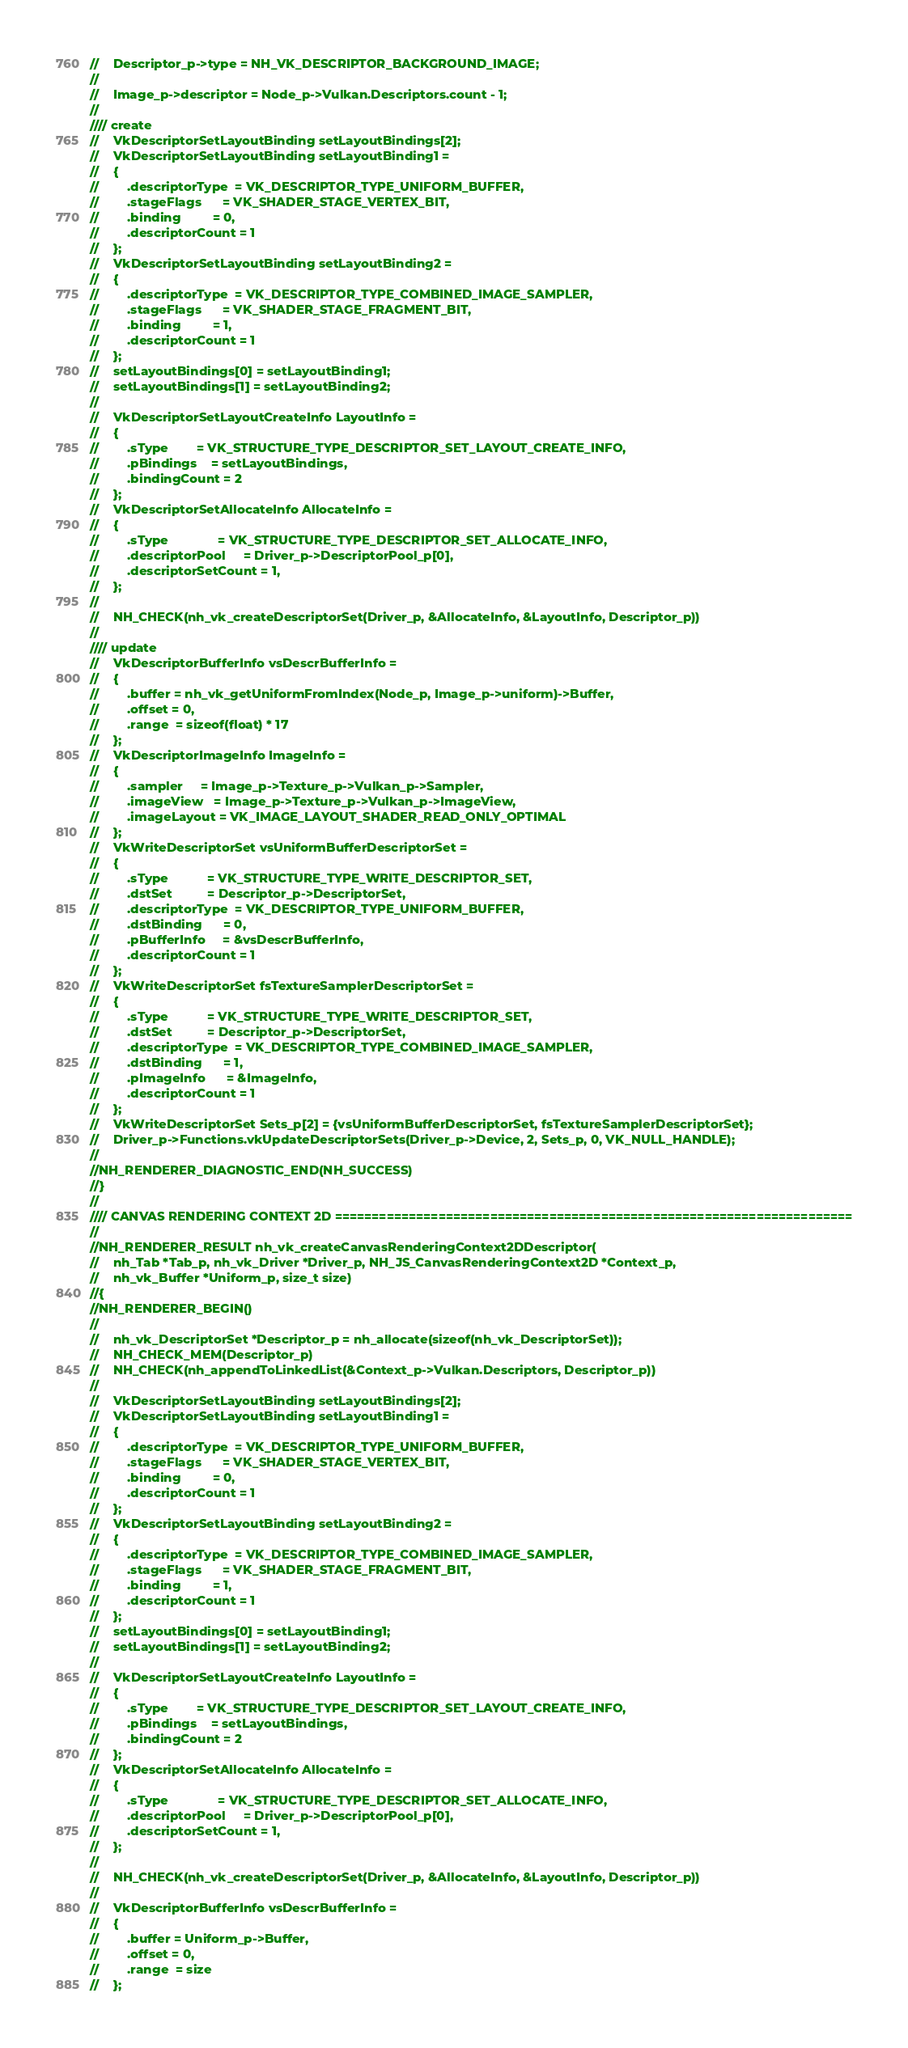<code> <loc_0><loc_0><loc_500><loc_500><_C_>//    Descriptor_p->type = NH_VK_DESCRIPTOR_BACKGROUND_IMAGE;
//
//    Image_p->descriptor = Node_p->Vulkan.Descriptors.count - 1;
//
//// create
//    VkDescriptorSetLayoutBinding setLayoutBindings[2];
//    VkDescriptorSetLayoutBinding setLayoutBinding1 =
//    {
//        .descriptorType  = VK_DESCRIPTOR_TYPE_UNIFORM_BUFFER,
//        .stageFlags      = VK_SHADER_STAGE_VERTEX_BIT,
//        .binding         = 0,
//        .descriptorCount = 1 
//    };
//    VkDescriptorSetLayoutBinding setLayoutBinding2 =
//    {
//        .descriptorType  = VK_DESCRIPTOR_TYPE_COMBINED_IMAGE_SAMPLER,
//        .stageFlags      = VK_SHADER_STAGE_FRAGMENT_BIT,
//        .binding         = 1,
//        .descriptorCount = 1 
//    };
//    setLayoutBindings[0] = setLayoutBinding1;
//    setLayoutBindings[1] = setLayoutBinding2;
//
//    VkDescriptorSetLayoutCreateInfo LayoutInfo = 
//    {
//        .sType        = VK_STRUCTURE_TYPE_DESCRIPTOR_SET_LAYOUT_CREATE_INFO,
//        .pBindings    = setLayoutBindings,
//        .bindingCount = 2
//    };
//    VkDescriptorSetAllocateInfo AllocateInfo = 
//    {
//        .sType              = VK_STRUCTURE_TYPE_DESCRIPTOR_SET_ALLOCATE_INFO,
//        .descriptorPool     = Driver_p->DescriptorPool_p[0],
//        .descriptorSetCount = 1,
//    };
//
//    NH_CHECK(nh_vk_createDescriptorSet(Driver_p, &AllocateInfo, &LayoutInfo, Descriptor_p))
//
//// update
//    VkDescriptorBufferInfo vsDescrBufferInfo = 
//    {
//        .buffer = nh_vk_getUniformFromIndex(Node_p, Image_p->uniform)->Buffer,
//        .offset = 0,
//        .range  = sizeof(float) * 17
//    };
//    VkDescriptorImageInfo ImageInfo = 
//    {
//        .sampler     = Image_p->Texture_p->Vulkan_p->Sampler,
//        .imageView   = Image_p->Texture_p->Vulkan_p->ImageView,
//        .imageLayout = VK_IMAGE_LAYOUT_SHADER_READ_ONLY_OPTIMAL
//    };
//    VkWriteDescriptorSet vsUniformBufferDescriptorSet = 
//    {
//        .sType           = VK_STRUCTURE_TYPE_WRITE_DESCRIPTOR_SET,
//        .dstSet          = Descriptor_p->DescriptorSet,
//        .descriptorType  = VK_DESCRIPTOR_TYPE_UNIFORM_BUFFER,
//        .dstBinding      = 0,
//        .pBufferInfo     = &vsDescrBufferInfo,
//        .descriptorCount = 1
//    };
//    VkWriteDescriptorSet fsTextureSamplerDescriptorSet = 
//    {
//        .sType           = VK_STRUCTURE_TYPE_WRITE_DESCRIPTOR_SET,
//        .dstSet          = Descriptor_p->DescriptorSet,
//        .descriptorType  = VK_DESCRIPTOR_TYPE_COMBINED_IMAGE_SAMPLER,
//        .dstBinding      = 1,
//        .pImageInfo      = &ImageInfo,
//        .descriptorCount = 1
//    };
//    VkWriteDescriptorSet Sets_p[2] = {vsUniformBufferDescriptorSet, fsTextureSamplerDescriptorSet};
//    Driver_p->Functions.vkUpdateDescriptorSets(Driver_p->Device, 2, Sets_p, 0, VK_NULL_HANDLE);
//
//NH_RENDERER_DIAGNOSTIC_END(NH_SUCCESS)
//}
//
//// CANVAS RENDERING CONTEXT 2D ======================================================================
//
//NH_RENDERER_RESULT nh_vk_createCanvasRenderingContext2DDescriptor(
//    nh_Tab *Tab_p, nh_vk_Driver *Driver_p, NH_JS_CanvasRenderingContext2D *Context_p, 
//    nh_vk_Buffer *Uniform_p, size_t size)
//{
//NH_RENDERER_BEGIN()
//
//    nh_vk_DescriptorSet *Descriptor_p = nh_allocate(sizeof(nh_vk_DescriptorSet));
//    NH_CHECK_MEM(Descriptor_p)
//    NH_CHECK(nh_appendToLinkedList(&Context_p->Vulkan.Descriptors, Descriptor_p))
//
//    VkDescriptorSetLayoutBinding setLayoutBindings[2];
//    VkDescriptorSetLayoutBinding setLayoutBinding1 =
//    {
//        .descriptorType  = VK_DESCRIPTOR_TYPE_UNIFORM_BUFFER,
//        .stageFlags      = VK_SHADER_STAGE_VERTEX_BIT,
//        .binding         = 0,
//        .descriptorCount = 1 
//    };
//    VkDescriptorSetLayoutBinding setLayoutBinding2 =
//    {
//        .descriptorType  = VK_DESCRIPTOR_TYPE_COMBINED_IMAGE_SAMPLER,
//        .stageFlags      = VK_SHADER_STAGE_FRAGMENT_BIT,
//        .binding         = 1,
//        .descriptorCount = 1 
//    };
//    setLayoutBindings[0] = setLayoutBinding1;
//    setLayoutBindings[1] = setLayoutBinding2;
//
//    VkDescriptorSetLayoutCreateInfo LayoutInfo = 
//    {
//        .sType        = VK_STRUCTURE_TYPE_DESCRIPTOR_SET_LAYOUT_CREATE_INFO,
//        .pBindings    = setLayoutBindings,
//        .bindingCount = 2
//    };
//    VkDescriptorSetAllocateInfo AllocateInfo = 
//    {
//        .sType              = VK_STRUCTURE_TYPE_DESCRIPTOR_SET_ALLOCATE_INFO,
//        .descriptorPool     = Driver_p->DescriptorPool_p[0],
//        .descriptorSetCount = 1,
//    };
//
//    NH_CHECK(nh_vk_createDescriptorSet(Driver_p, &AllocateInfo, &LayoutInfo, Descriptor_p))
//
//    VkDescriptorBufferInfo vsDescrBufferInfo = 
//    {
//        .buffer = Uniform_p->Buffer,
//        .offset = 0,
//        .range  = size
//    };</code> 